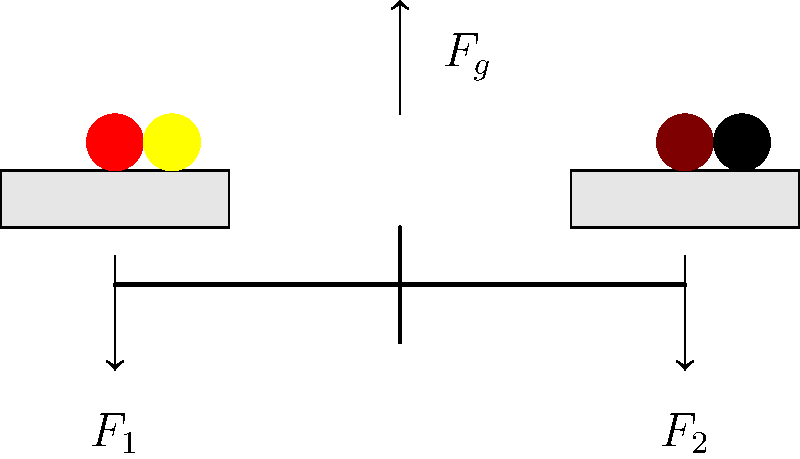In the context of promoting diversity in mainstream streaming platforms, consider the force diagram of a balanced scale shown above. The scale represents equal representation, with diverse figures on both sides. If $F_1$ and $F_2$ are the upward forces exerted by the scale on each side, and $F_g$ is the total gravitational force acting downward, what is the relationship between these forces when the scale is in equilibrium? To understand the relationship between the forces in this balanced scale diagram, let's follow these steps:

1. Identify the forces:
   - $F_1$: Upward force on the left side of the scale
   - $F_2$: Upward force on the right side of the scale
   - $F_g$: Total gravitational force acting downward (combined weight of all figures)

2. Consider the condition for equilibrium:
   In a balanced state, the sum of all forces must equal zero.

3. Apply Newton's Second Law for equilibrium:
   $$\sum F = 0$$

4. Break down the forces in vertical direction:
   $$F_1 + F_2 - F_g = 0$$

5. Rearrange the equation:
   $$F_1 + F_2 = F_g$$

This equation shows that the sum of the upward forces $(F_1 + F_2)$ must equal the total gravitational force $(F_g)$ for the scale to be in equilibrium.

6. Consider the balance of the scale:
   Since the scale is evenly balanced (representing equal representation), we can infer that:
   $$F_1 = F_2$$

7. Substituting this into our equation:
   $$F_1 + F_1 = F_g$$
   $$2F_1 = F_g$$
   $$F_1 = F_2 = \frac{F_g}{2}$$

This final equation demonstrates that each upward force is equal to half of the total gravitational force, reflecting the equal distribution of diverse representation on both sides of the scale.
Answer: $F_1 = F_2 = \frac{F_g}{2}$ 